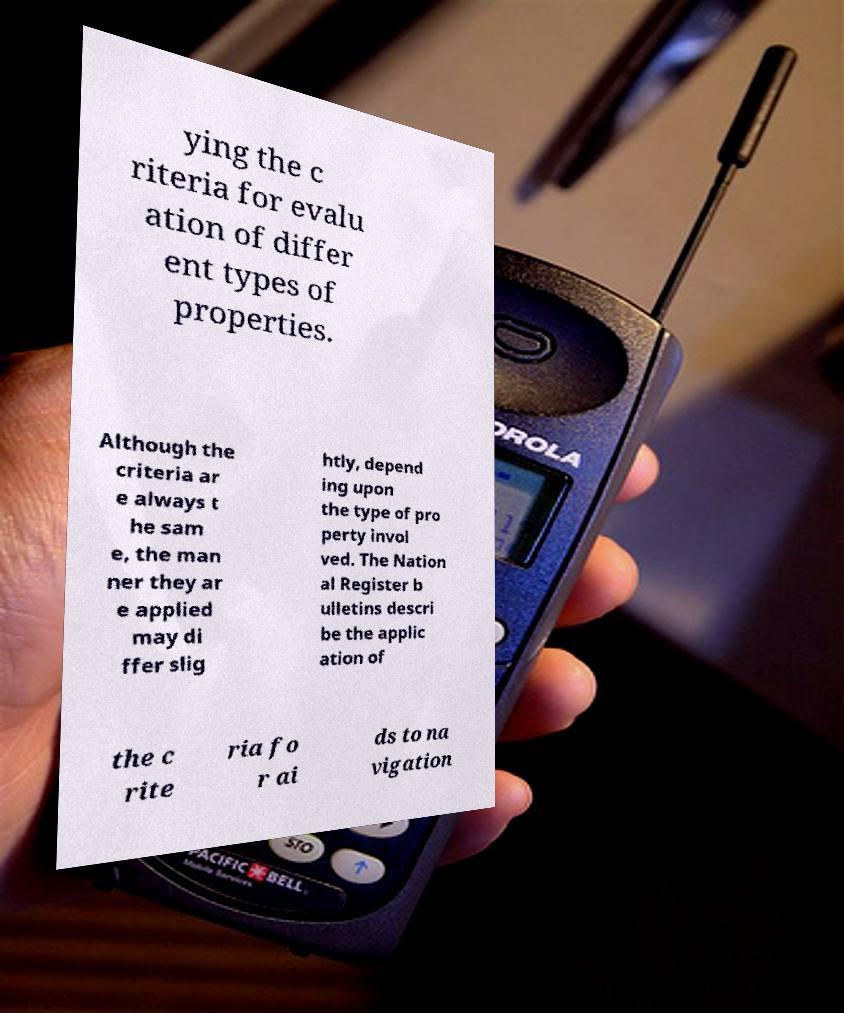For documentation purposes, I need the text within this image transcribed. Could you provide that? ying the c riteria for evalu ation of differ ent types of properties. Although the criteria ar e always t he sam e, the man ner they ar e applied may di ffer slig htly, depend ing upon the type of pro perty invol ved. The Nation al Register b ulletins descri be the applic ation of the c rite ria fo r ai ds to na vigation 